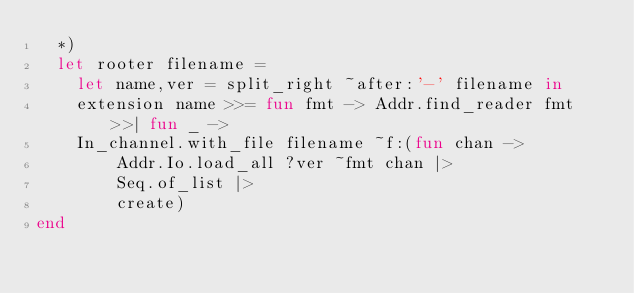Convert code to text. <code><loc_0><loc_0><loc_500><loc_500><_OCaml_>  *)
  let rooter filename =
    let name,ver = split_right ~after:'-' filename in
    extension name >>= fun fmt -> Addr.find_reader fmt >>| fun _ ->
    In_channel.with_file filename ~f:(fun chan ->
        Addr.Io.load_all ?ver ~fmt chan |>
        Seq.of_list |>
        create)
end
</code> 